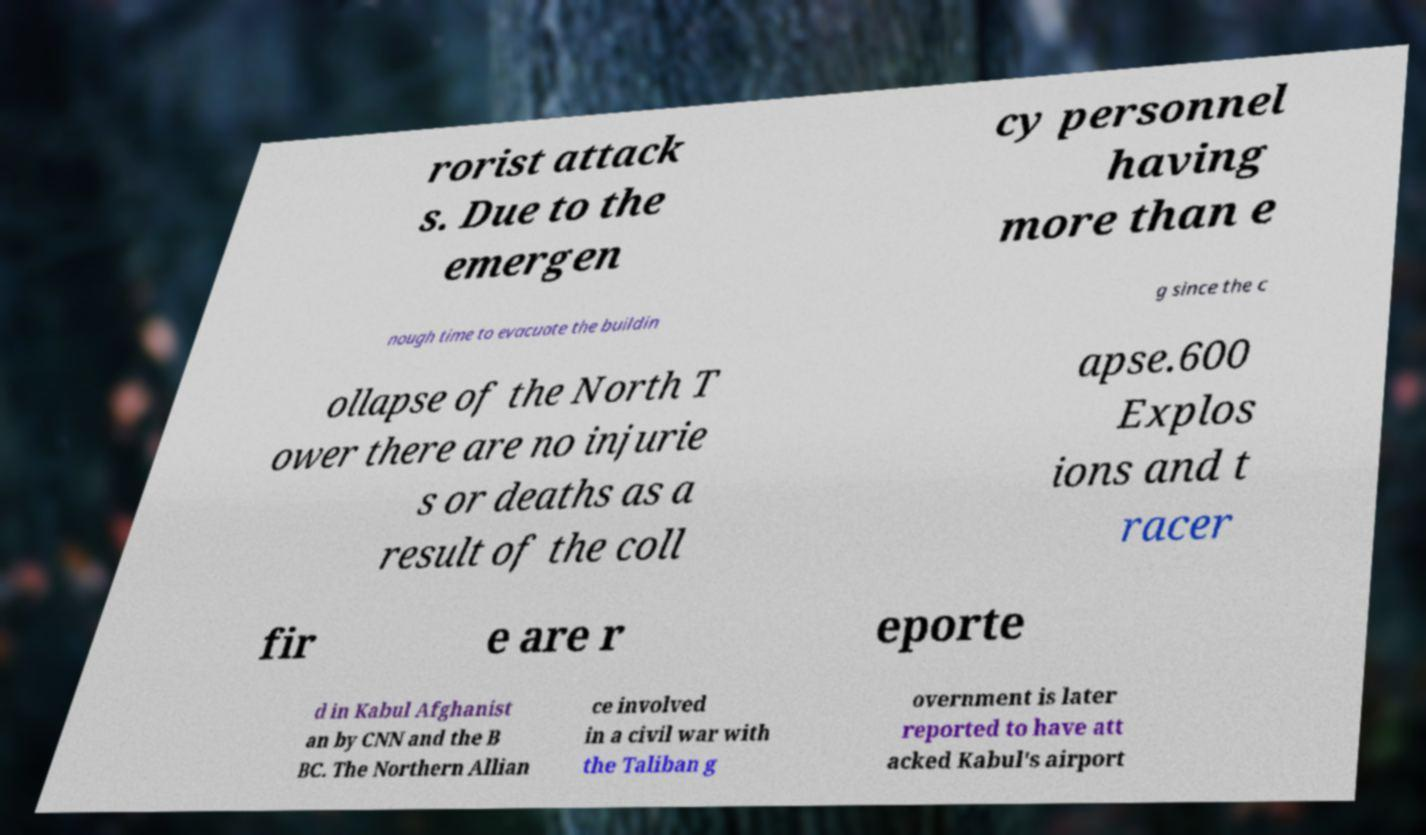For documentation purposes, I need the text within this image transcribed. Could you provide that? rorist attack s. Due to the emergen cy personnel having more than e nough time to evacuate the buildin g since the c ollapse of the North T ower there are no injurie s or deaths as a result of the coll apse.600 Explos ions and t racer fir e are r eporte d in Kabul Afghanist an by CNN and the B BC. The Northern Allian ce involved in a civil war with the Taliban g overnment is later reported to have att acked Kabul's airport 